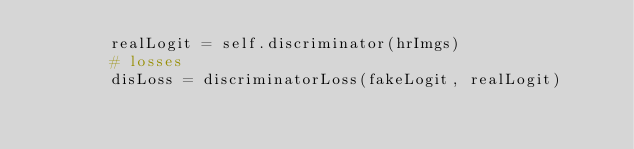Convert code to text. <code><loc_0><loc_0><loc_500><loc_500><_Python_>        realLogit = self.discriminator(hrImgs)
        # losses
        disLoss = discriminatorLoss(fakeLogit, realLogit)</code> 